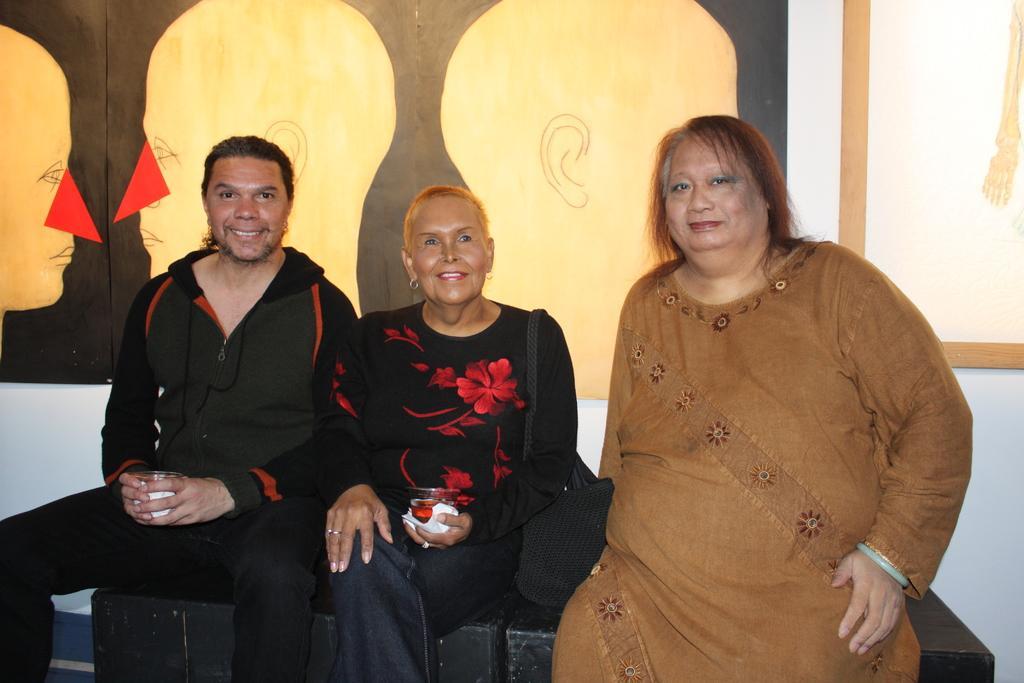Describe this image in one or two sentences. This image consists of three persons. On the left, the two persons are wearing the black dresses. On the right, the woman is wearing a brown dress. In the background, we can see a wall on which there are frames. 